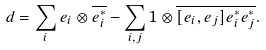Convert formula to latex. <formula><loc_0><loc_0><loc_500><loc_500>d = \sum _ { i } e _ { i } \otimes \overline { e _ { i } ^ { * } } - \sum _ { i , j } 1 \otimes \overline { [ e _ { i } , e _ { j } ] } \overline { e _ { i } ^ { * } } \overline { e _ { j } ^ { * } } .</formula> 